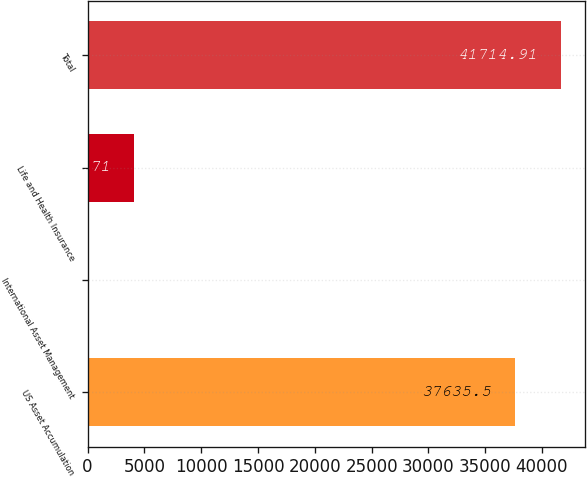Convert chart to OTSL. <chart><loc_0><loc_0><loc_500><loc_500><bar_chart><fcel>US Asset Accumulation<fcel>International Asset Management<fcel>Life and Health Insurance<fcel>Total<nl><fcel>37635.5<fcel>35.3<fcel>4114.71<fcel>41714.9<nl></chart> 